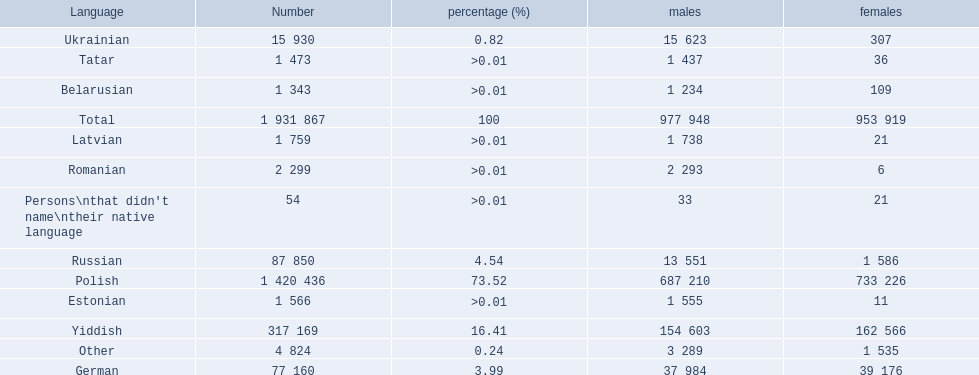How many languages are there? Polish, Yiddish, Russian, German, Ukrainian, Romanian, Latvian, Estonian, Tatar, Belarusian. Which language do more people speak? Polish. 